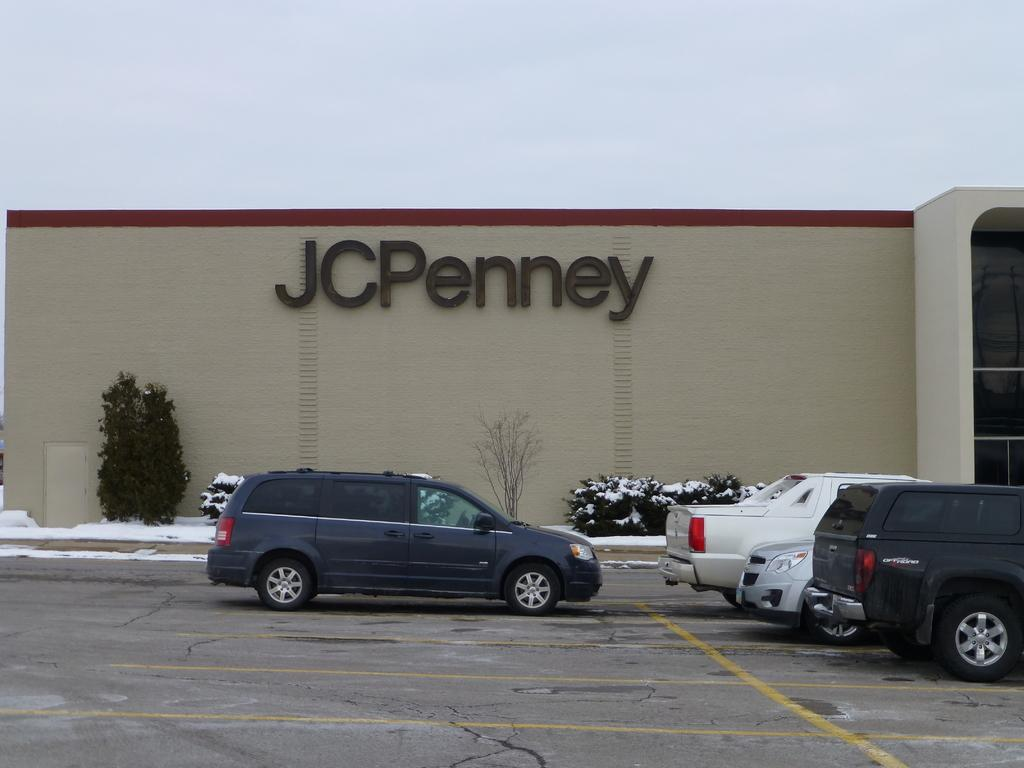What can be seen on the road in the image? There are cars on the road in the image. What is written or displayed above the wall in the image? There is a wall with text above it in the image. What type of vegetation is in front of the wall in the image? There are plants in front of the wall in the image. What is the ground made of in the image? The scene takes place on snow. What can be seen above the scene in the image? The sky is visible above the scene. What invention is being sold at the market in the image? There is no market or invention present in the image. What is the smell of the plants in the image? The image does not provide information about the smell of the plants. 